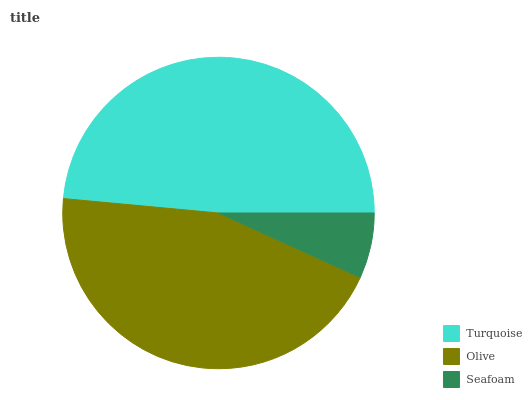Is Seafoam the minimum?
Answer yes or no. Yes. Is Turquoise the maximum?
Answer yes or no. Yes. Is Olive the minimum?
Answer yes or no. No. Is Olive the maximum?
Answer yes or no. No. Is Turquoise greater than Olive?
Answer yes or no. Yes. Is Olive less than Turquoise?
Answer yes or no. Yes. Is Olive greater than Turquoise?
Answer yes or no. No. Is Turquoise less than Olive?
Answer yes or no. No. Is Olive the high median?
Answer yes or no. Yes. Is Olive the low median?
Answer yes or no. Yes. Is Turquoise the high median?
Answer yes or no. No. Is Seafoam the low median?
Answer yes or no. No. 